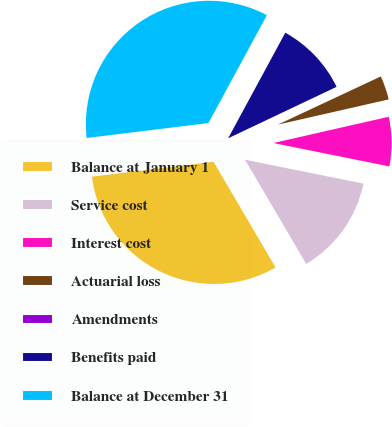<chart> <loc_0><loc_0><loc_500><loc_500><pie_chart><fcel>Balance at January 1<fcel>Service cost<fcel>Interest cost<fcel>Actuarial loss<fcel>Amendments<fcel>Benefits paid<fcel>Balance at December 31<nl><fcel>31.51%<fcel>13.38%<fcel>6.73%<fcel>3.41%<fcel>0.08%<fcel>10.05%<fcel>34.84%<nl></chart> 